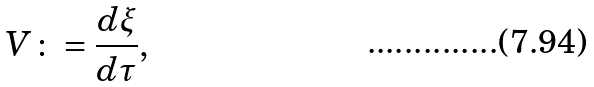<formula> <loc_0><loc_0><loc_500><loc_500>V \colon = \frac { d \xi } { d \tau } ,</formula> 